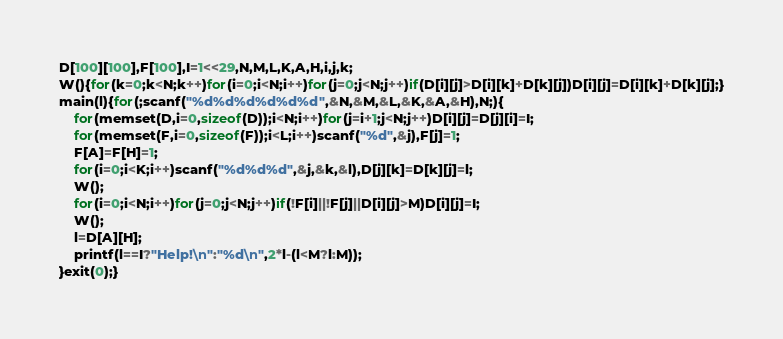<code> <loc_0><loc_0><loc_500><loc_500><_C_>D[100][100],F[100],I=1<<29,N,M,L,K,A,H,i,j,k;
W(){for(k=0;k<N;k++)for(i=0;i<N;i++)for(j=0;j<N;j++)if(D[i][j]>D[i][k]+D[k][j])D[i][j]=D[i][k]+D[k][j];}
main(l){for(;scanf("%d%d%d%d%d%d",&N,&M,&L,&K,&A,&H),N;){
	for(memset(D,i=0,sizeof(D));i<N;i++)for(j=i+1;j<N;j++)D[i][j]=D[j][i]=I;
	for(memset(F,i=0,sizeof(F));i<L;i++)scanf("%d",&j),F[j]=1;
	F[A]=F[H]=1;
	for(i=0;i<K;i++)scanf("%d%d%d",&j,&k,&l),D[j][k]=D[k][j]=l;
	W();
	for(i=0;i<N;i++)for(j=0;j<N;j++)if(!F[i]||!F[j]||D[i][j]>M)D[i][j]=I;
	W();
	l=D[A][H];
	printf(l==I?"Help!\n":"%d\n",2*l-(l<M?l:M));
}exit(0);}</code> 